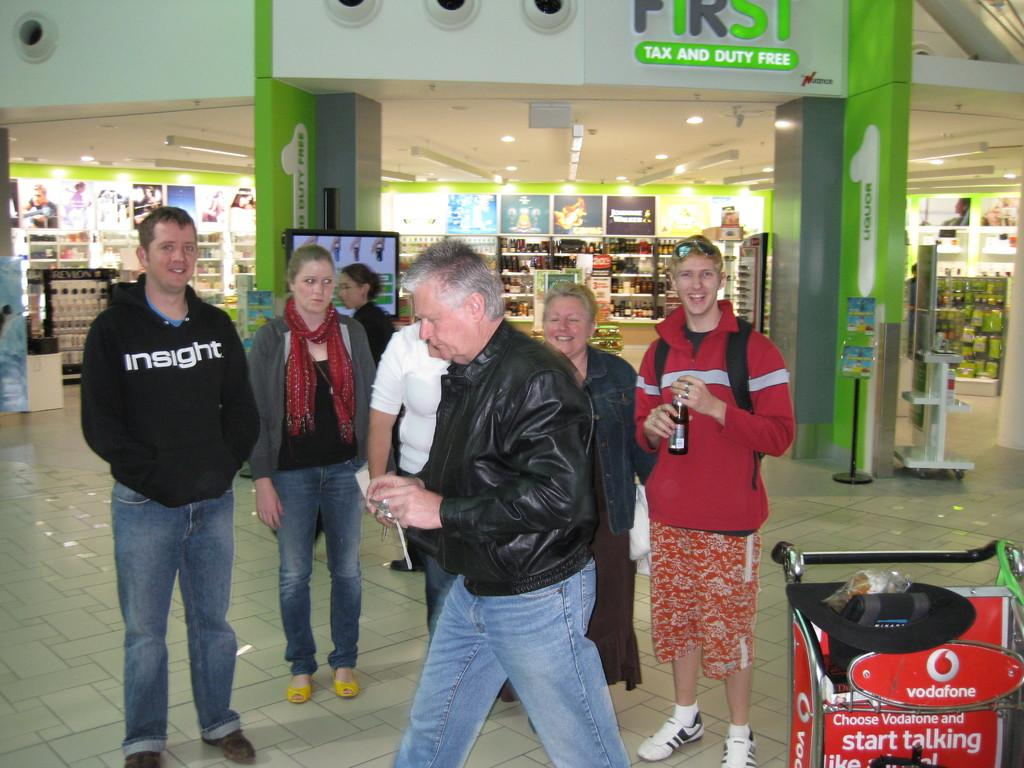Who is the main subject in the image? There is a man in the image. What is the man doing in the image? The man is walking. What is the man wearing in the image? The man is wearing a black coat and blue jeans. What are the other people in the image doing? The people are standing and looking at the man. Where does the image appear to be set? The image appears to be set in a store. What is the reaction of the industry to the man's actions in the image? There is no mention of an industry or its reaction in the image. The image only shows a man walking in a store while other people observe him. 